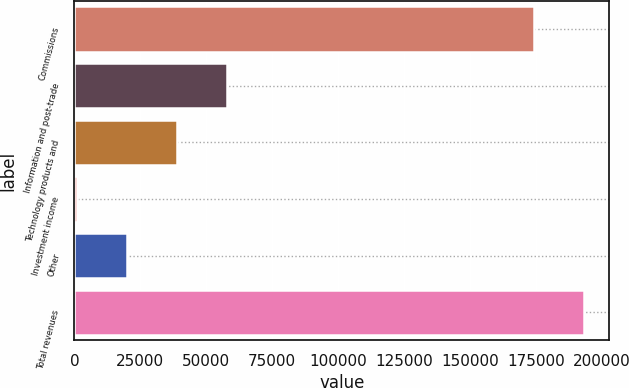Convert chart. <chart><loc_0><loc_0><loc_500><loc_500><bar_chart><fcel>Commissions<fcel>Information and post-trade<fcel>Technology products and<fcel>Investment income<fcel>Other<fcel>Total revenues<nl><fcel>174199<fcel>57991.9<fcel>39013.6<fcel>1057<fcel>20035.3<fcel>193177<nl></chart> 